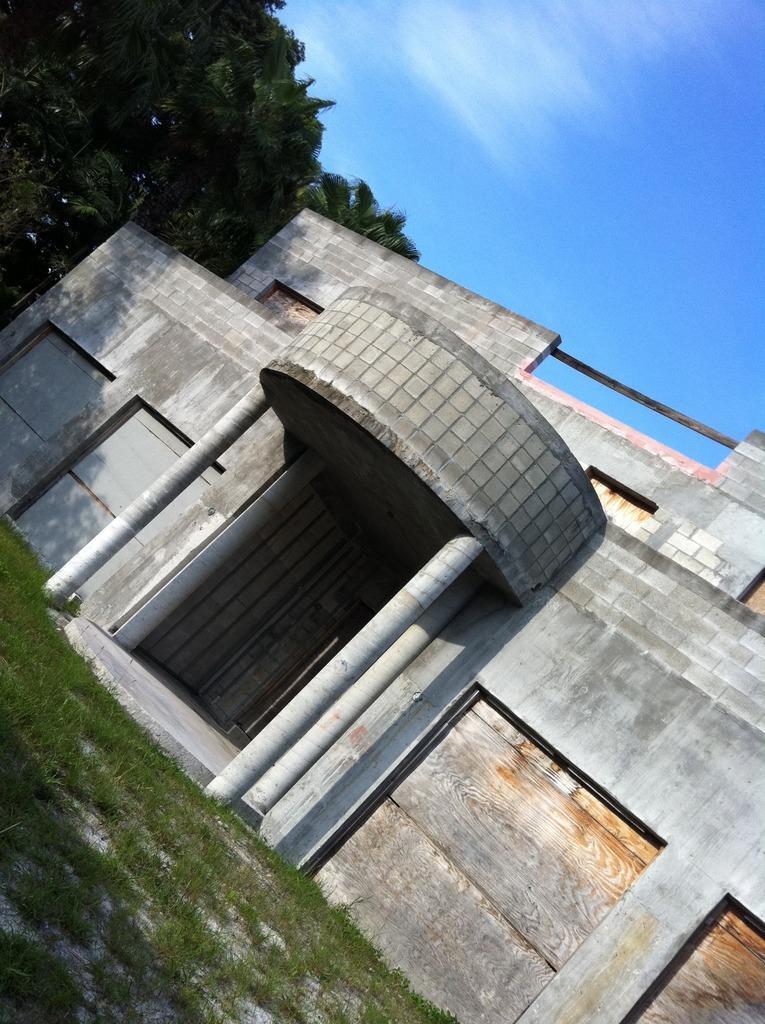Could you give a brief overview of what you see in this image? In this picture I can see a building, grass and trees. In the background I can see the sky. 